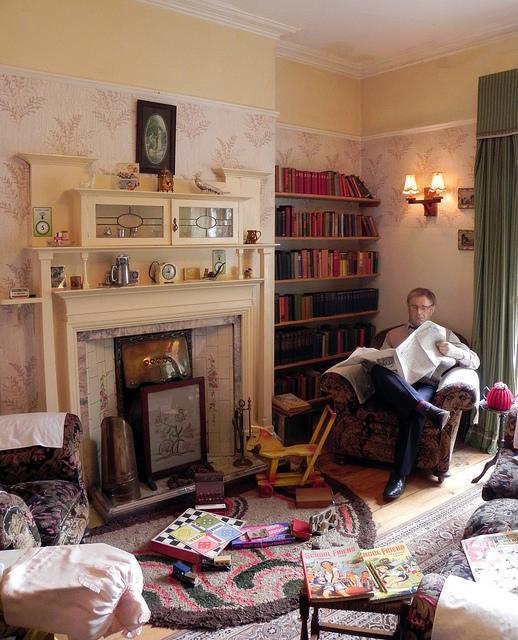How is the game laying on top of the chess board called?
Choose the right answer from the provided options to respond to the question.
Options: Chess, monopoly, life, ludo. Ludo. 